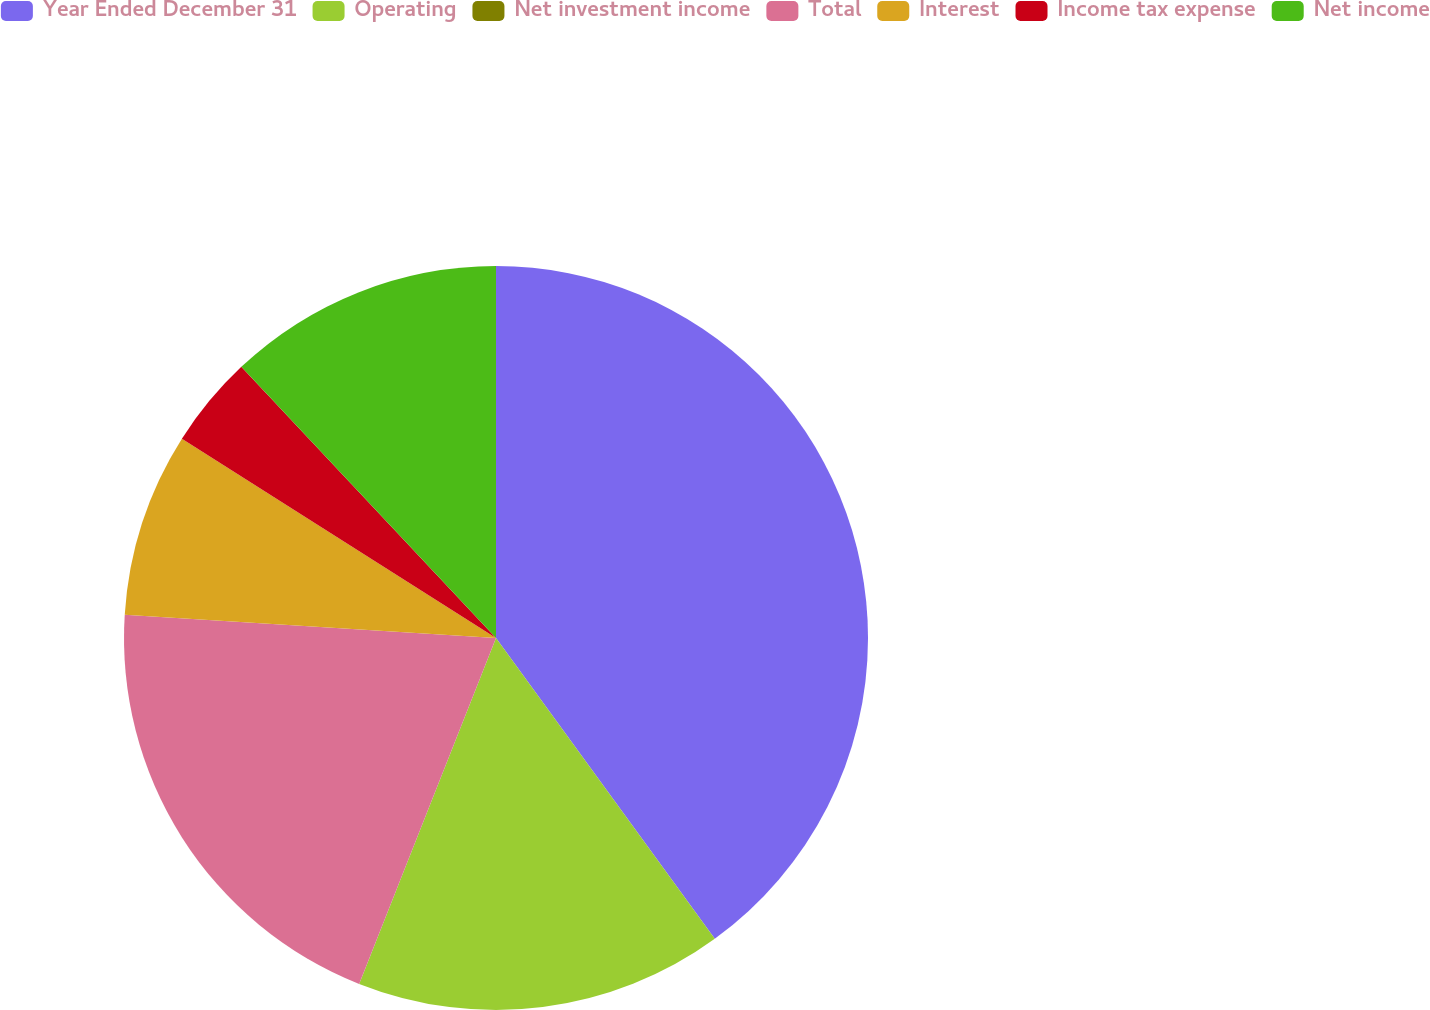Convert chart. <chart><loc_0><loc_0><loc_500><loc_500><pie_chart><fcel>Year Ended December 31<fcel>Operating<fcel>Net investment income<fcel>Total<fcel>Interest<fcel>Income tax expense<fcel>Net income<nl><fcel>39.99%<fcel>16.0%<fcel>0.0%<fcel>20.0%<fcel>8.0%<fcel>4.0%<fcel>12.0%<nl></chart> 